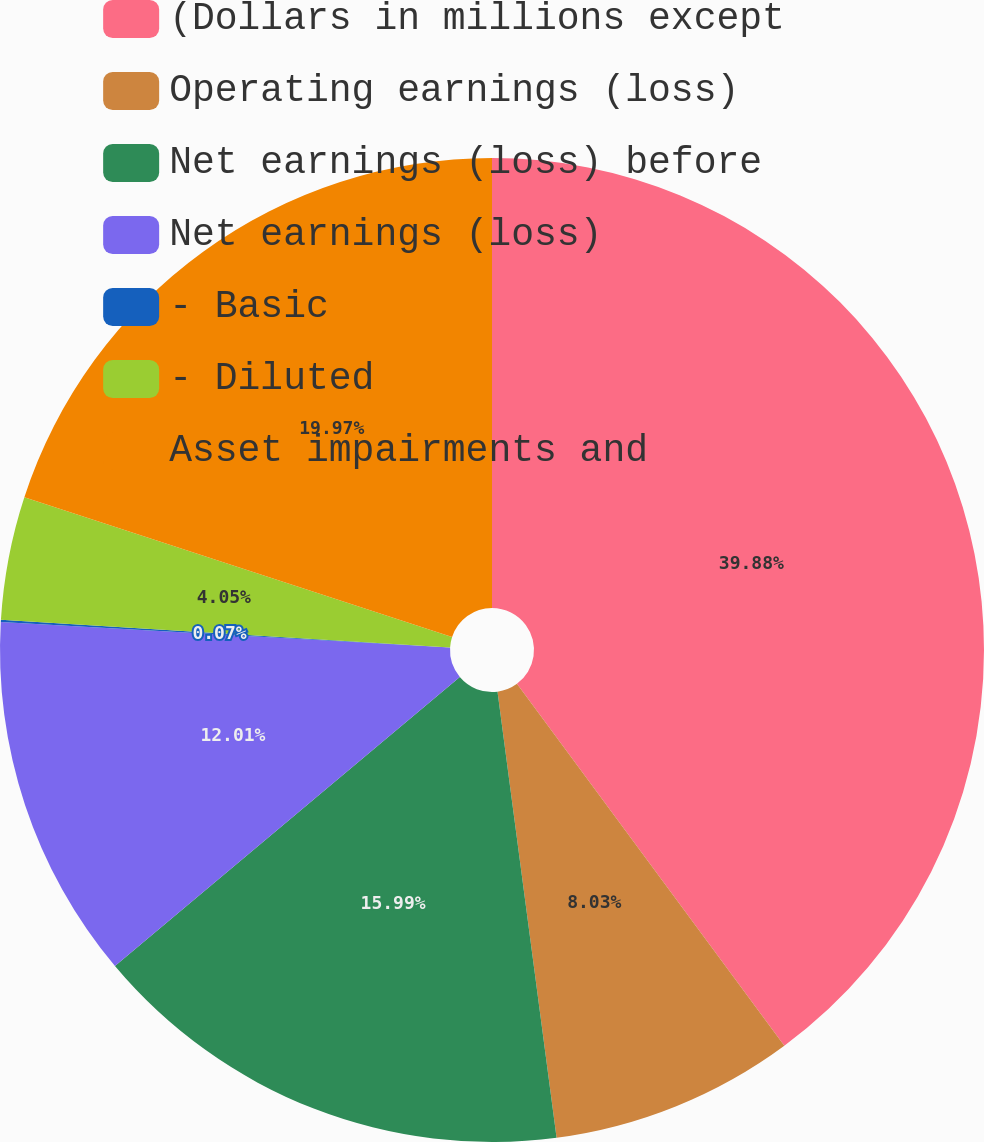Convert chart to OTSL. <chart><loc_0><loc_0><loc_500><loc_500><pie_chart><fcel>(Dollars in millions except<fcel>Operating earnings (loss)<fcel>Net earnings (loss) before<fcel>Net earnings (loss)<fcel>- Basic<fcel>- Diluted<fcel>Asset impairments and<nl><fcel>39.87%<fcel>8.03%<fcel>15.99%<fcel>12.01%<fcel>0.07%<fcel>4.05%<fcel>19.97%<nl></chart> 